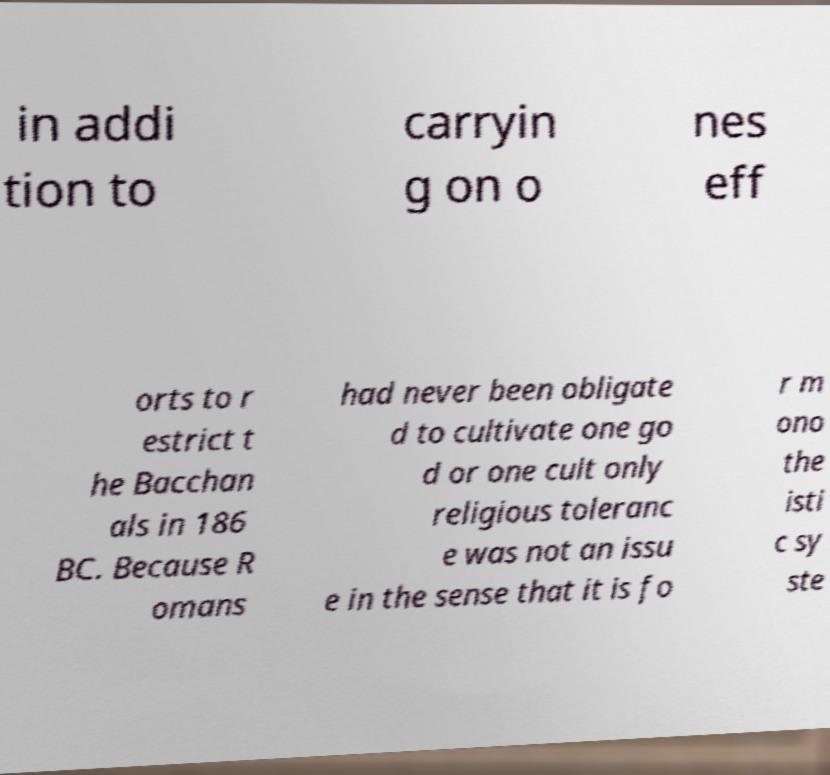Can you read and provide the text displayed in the image?This photo seems to have some interesting text. Can you extract and type it out for me? in addi tion to carryin g on o nes eff orts to r estrict t he Bacchan als in 186 BC. Because R omans had never been obligate d to cultivate one go d or one cult only religious toleranc e was not an issu e in the sense that it is fo r m ono the isti c sy ste 